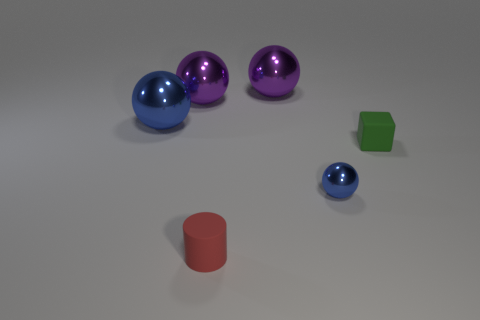There is a sphere that is the same size as the red matte object; what is its material?
Your answer should be very brief. Metal. Are there any other small things that have the same material as the red thing?
Give a very brief answer. Yes. There is a sphere that is both behind the tiny cube and on the right side of the tiny red cylinder; what color is it?
Your answer should be very brief. Purple. What number of other objects are there of the same color as the tiny metallic object?
Keep it short and to the point. 1. What material is the blue object behind the metallic thing in front of the large blue metallic object left of the small cube?
Provide a succinct answer. Metal. What number of cylinders are purple metallic things or small rubber objects?
Offer a very short reply. 1. How many metallic objects are right of the big purple metallic sphere that is behind the big purple metallic object on the left side of the tiny red cylinder?
Your answer should be very brief. 1. Do the tiny green rubber thing and the small blue metallic thing have the same shape?
Your answer should be very brief. No. Is the material of the blue ball that is in front of the tiny matte cube the same as the tiny red thing that is on the right side of the large blue metal object?
Your response must be concise. No. What number of things are big spheres that are right of the large blue sphere or blue objects behind the tiny blue shiny object?
Your answer should be very brief. 3. 